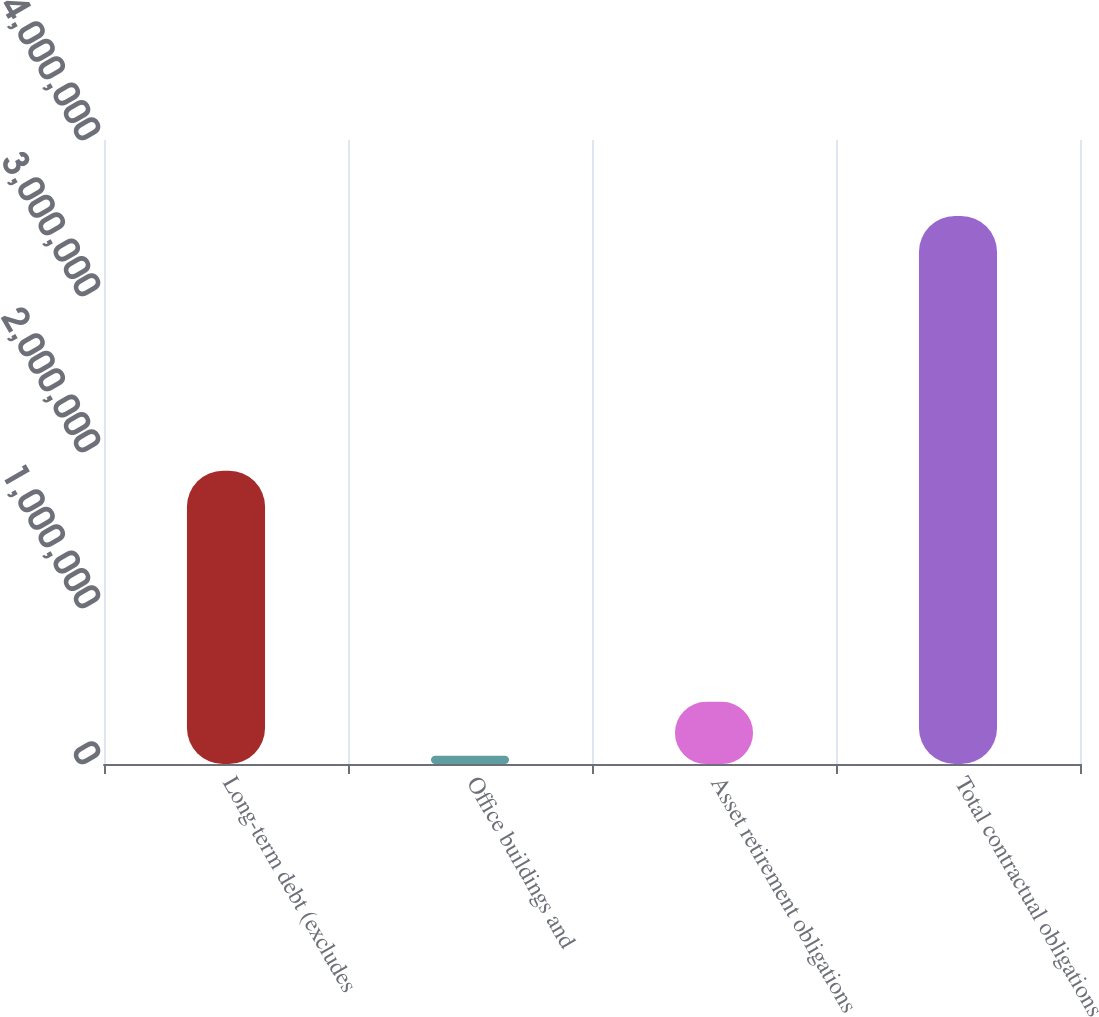Convert chart to OTSL. <chart><loc_0><loc_0><loc_500><loc_500><bar_chart><fcel>Long-term debt (excludes<fcel>Office buildings and<fcel>Asset retirement obligations<fcel>Total contractual obligations<nl><fcel>1.88e+06<fcel>52894<fcel>398878<fcel>3.51274e+06<nl></chart> 